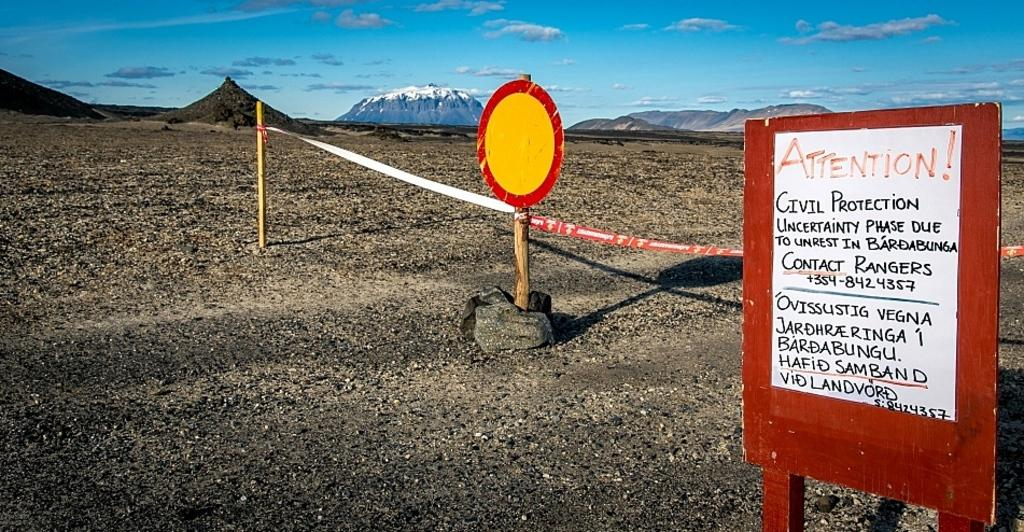Provide a one-sentence caption for the provided image. A barren gravel covered landscape near mountains with an Attention sign warning of civil protection uncertainty due to unrest in Bardabunga. 